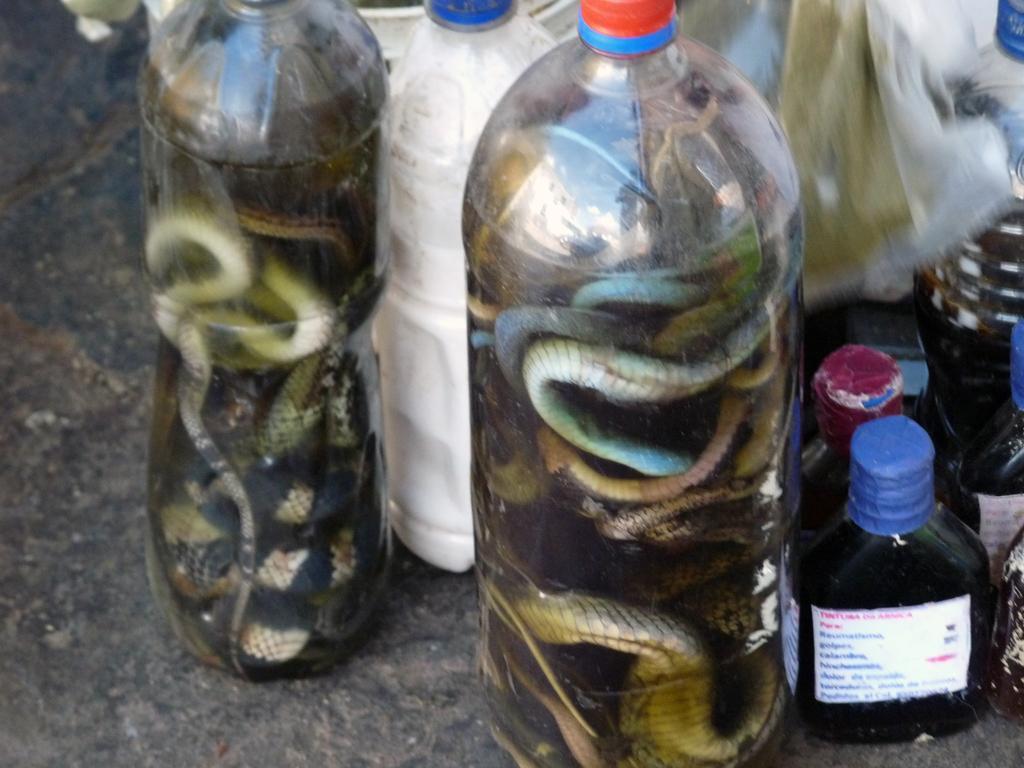What objects are present in the image? There are bottles in the image. What is inside the bottles? The bottles contain snakes. Where are the bottles located? The bottles are on a table. What type of protest is happening in the image? There is no protest present in the image; it features bottles containing snakes on a table. Is the queen mentioned or depicted in the image? There is no mention or depiction of a queen in the image. 